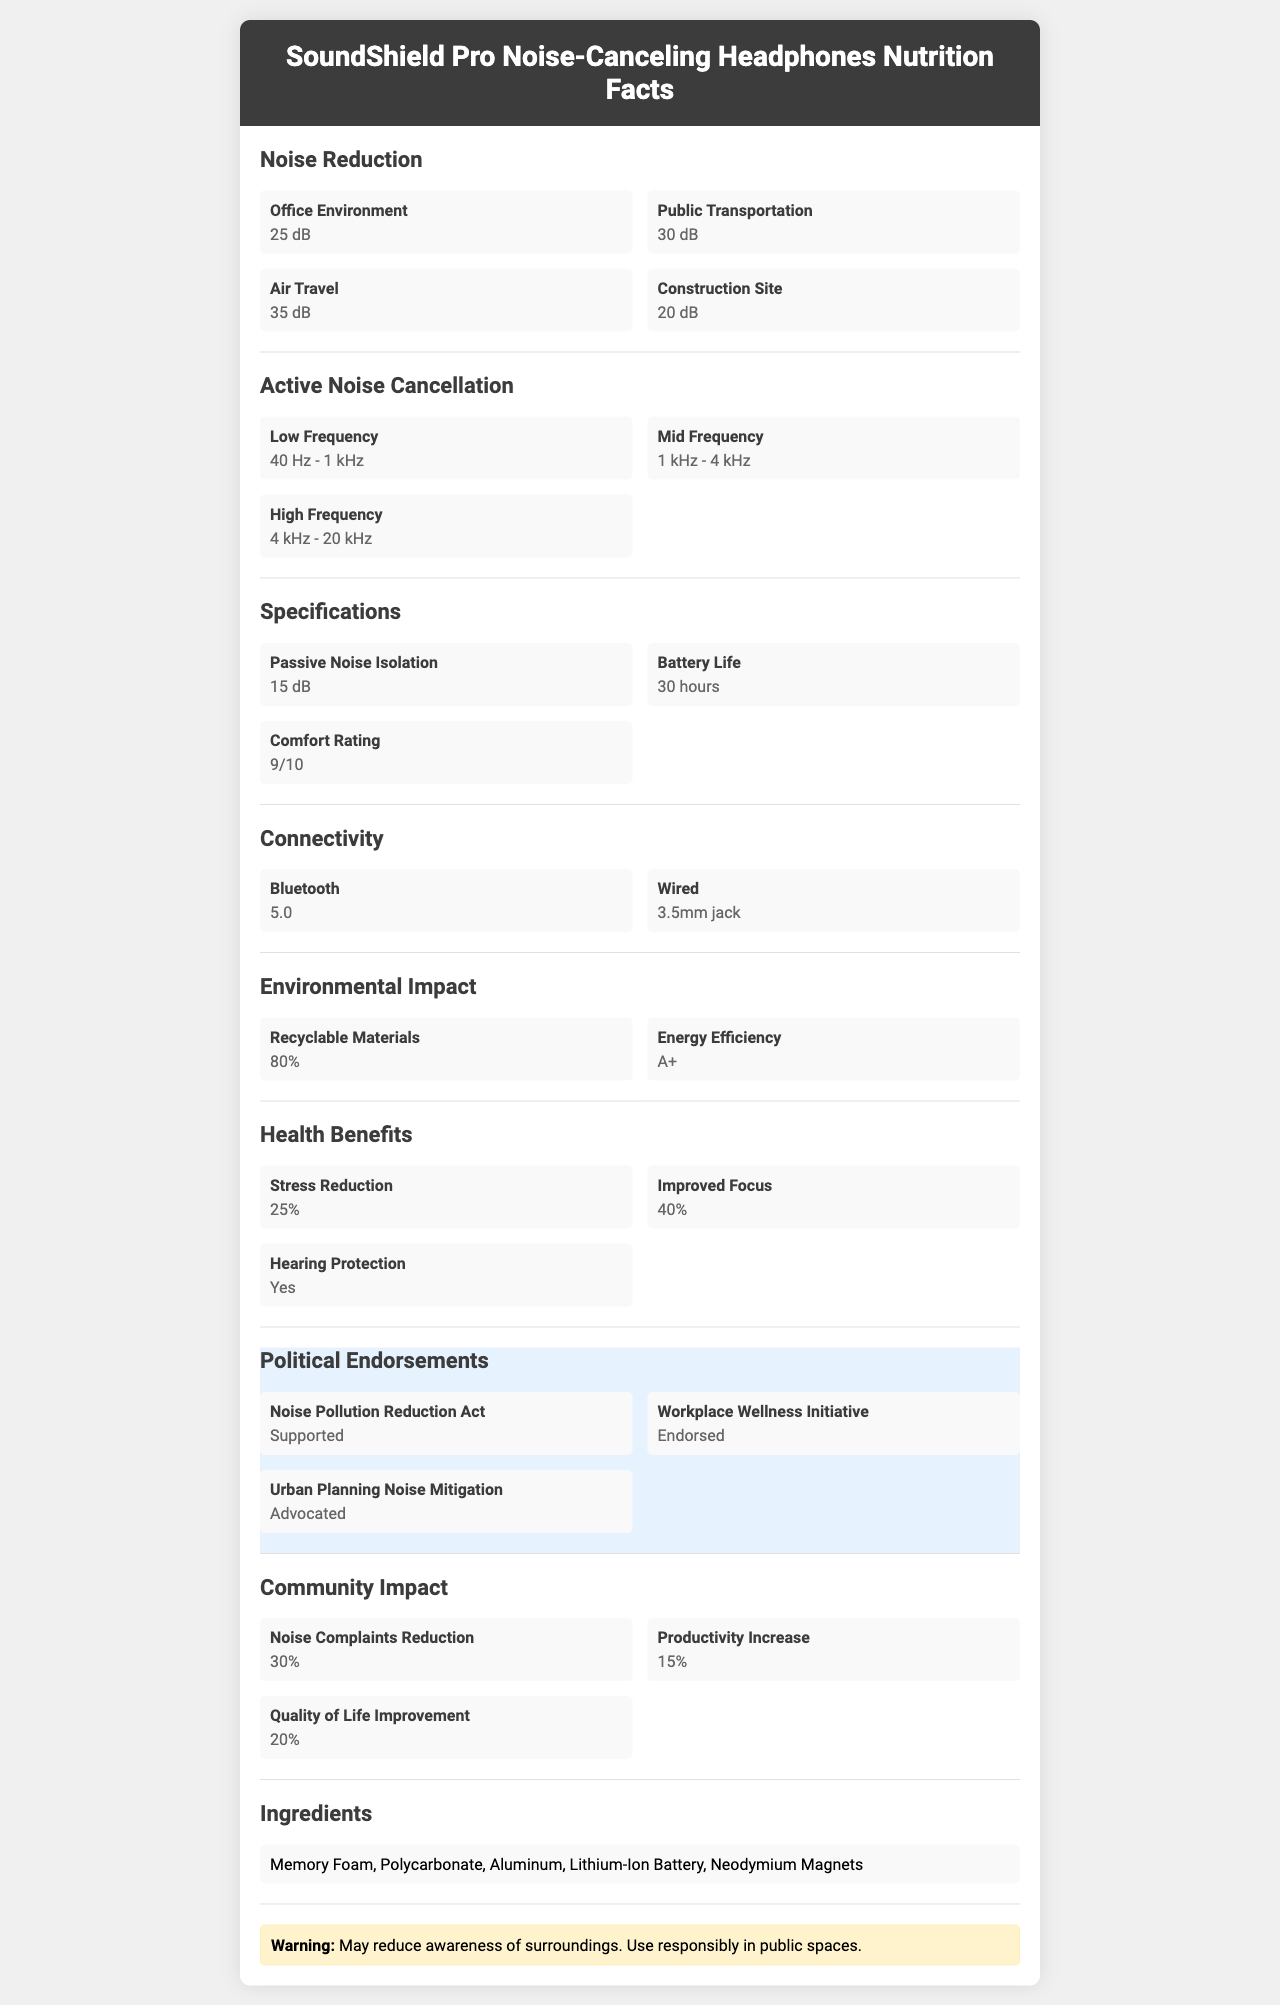What is the noise reduction rating for air travel? The document states that the noise reduction for air travel is 35 dB.
Answer: 35 dB What frequency range does the active noise cancellation cover for low frequencies? The document specifies the low-frequency range for active noise cancellation is 40 Hz - 1 kHz.
Answer: 40 Hz - 1 kHz How long is the battery life of the SoundShield Pro Noise-Canceling Headphones? The document states that the battery life of the headphones is 30 hours.
Answer: 30 hours What percentage of materials used in the headphones are recyclable? The document specifies that 80% of the materials used in these headphones are recyclable.
Answer: 80% What types of connectivity options are available for the headphones? The document mentions connectivity options as Bluetooth 5.0 and a 3.5mm jack.
Answer: Bluetooth 5.0 and 3.5mm jack Which environment has the lowest noise reduction rating? 
A. Office Environment
B. Public Transportation
C. Air Travel
D. Construction Site The document shows that the noise reduction rating for a construction site is 20 dB, the lowest among the listed environments.
Answer: D. Construction Site What is the comfort rating of the headphones on a scale of 1 to 10? 
1. 5
2. 7
3. 9
4. 10 The document specifies the comfort rating as 9 out of 10.
Answer: 3. 9 Are the headphones FCC approved? The document states that the headphones are FCC approved.
Answer: Yes Summarize the main features and benefits of the SoundShield Pro Noise-Canceling Headphones. The headphones are detailed in terms of their noise reduction capabilities, battery life, comfort, connectivity options, and environmental and health benefits, making them a well-rounded choice for consumers.
Answer: The SoundShield Pro Noise-Canceling Headphones provide effective noise reduction for various environments, including public transportation, air travel, offices, and construction sites. They offer active noise cancellation across low, mid, and high frequencies and have a battery life of 30 hours. The headphones are comfortable, connect via Bluetooth 5.0 or a 3.5mm jack, and are made with 80% recyclable materials. They offer health benefits such as stress reduction and improved focus, and have received political and regulatory endorsements. What materials are used to make the SoundShield Pro Noise-Canceling Headphones? The document lists Memory Foam, Polycarbonate, Aluminum, Lithium-Ion Battery, and Neodymium Magnets as the materials used.
Answer: Memory Foam, Polycarbonate, Aluminum, Lithium-Ion Battery, Neodymium Magnets What is the reduction in noise complaints achieved due to these headphones? The document indicates that the reduction in noise complaints is 30%.
Answer: 30% What is the frequency range for active noise cancellation at high frequencies? The document states that the high-frequency range for active noise cancellation is 4 kHz - 20 kHz.
Answer: 4 kHz - 20 kHz Has the product been endorsed in any political campaigns? The document mentions that the product has been endorsed by the Noise Pollution Reduction Act, Workplace Wellness Initiative, and Urban Planning Noise Mitigation.
Answer: Yes What is the energy efficiency rating of the headphones? The document specifies that the energy efficiency rating is A+.
Answer: A+ Can the data sufficiently report on the safety of using headphones in a public space? The document provides a warning that the headphones may reduce awareness of surroundings, but it doesn't provide detailed data on safety implications or guidelines for public use.
Answer: Not enough information 